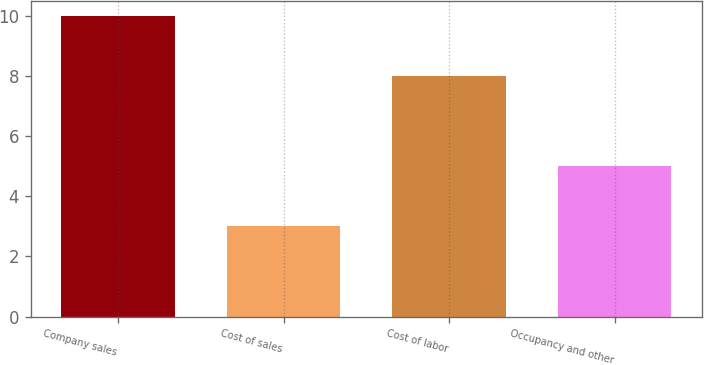<chart> <loc_0><loc_0><loc_500><loc_500><bar_chart><fcel>Company sales<fcel>Cost of sales<fcel>Cost of labor<fcel>Occupancy and other<nl><fcel>10<fcel>3<fcel>8<fcel>5<nl></chart> 